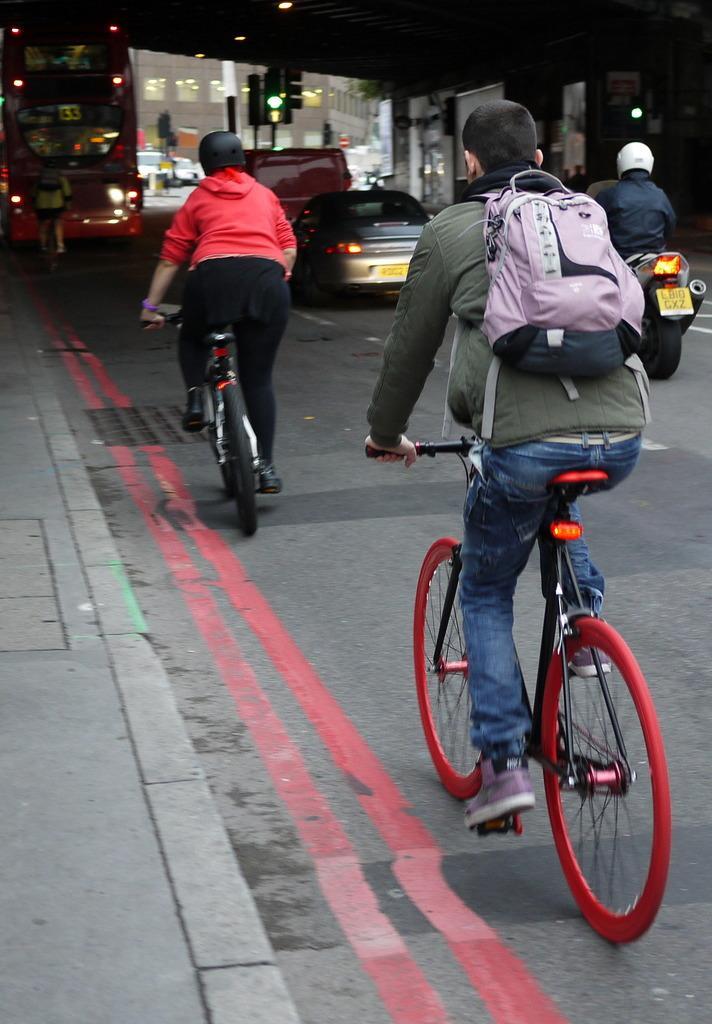Can you describe this image briefly? In this image I can see two riding bicycle and one person wearing helmet and riding motor cycle. On the road I can see a car,bus and one person is walking and I can also see a signal light. Among them one person is wearing a bag. 